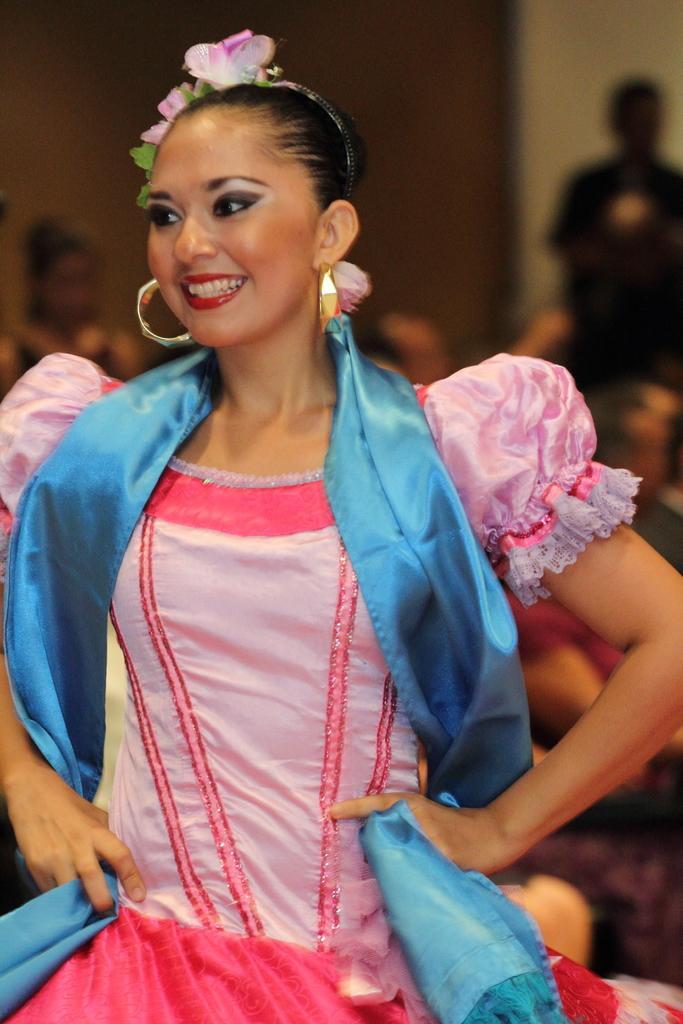Describe this image in one or two sentences. In the foreground of this picture, there is a woman in pink color dress and having smile on her face. In the background, we can see persons and the wall. 